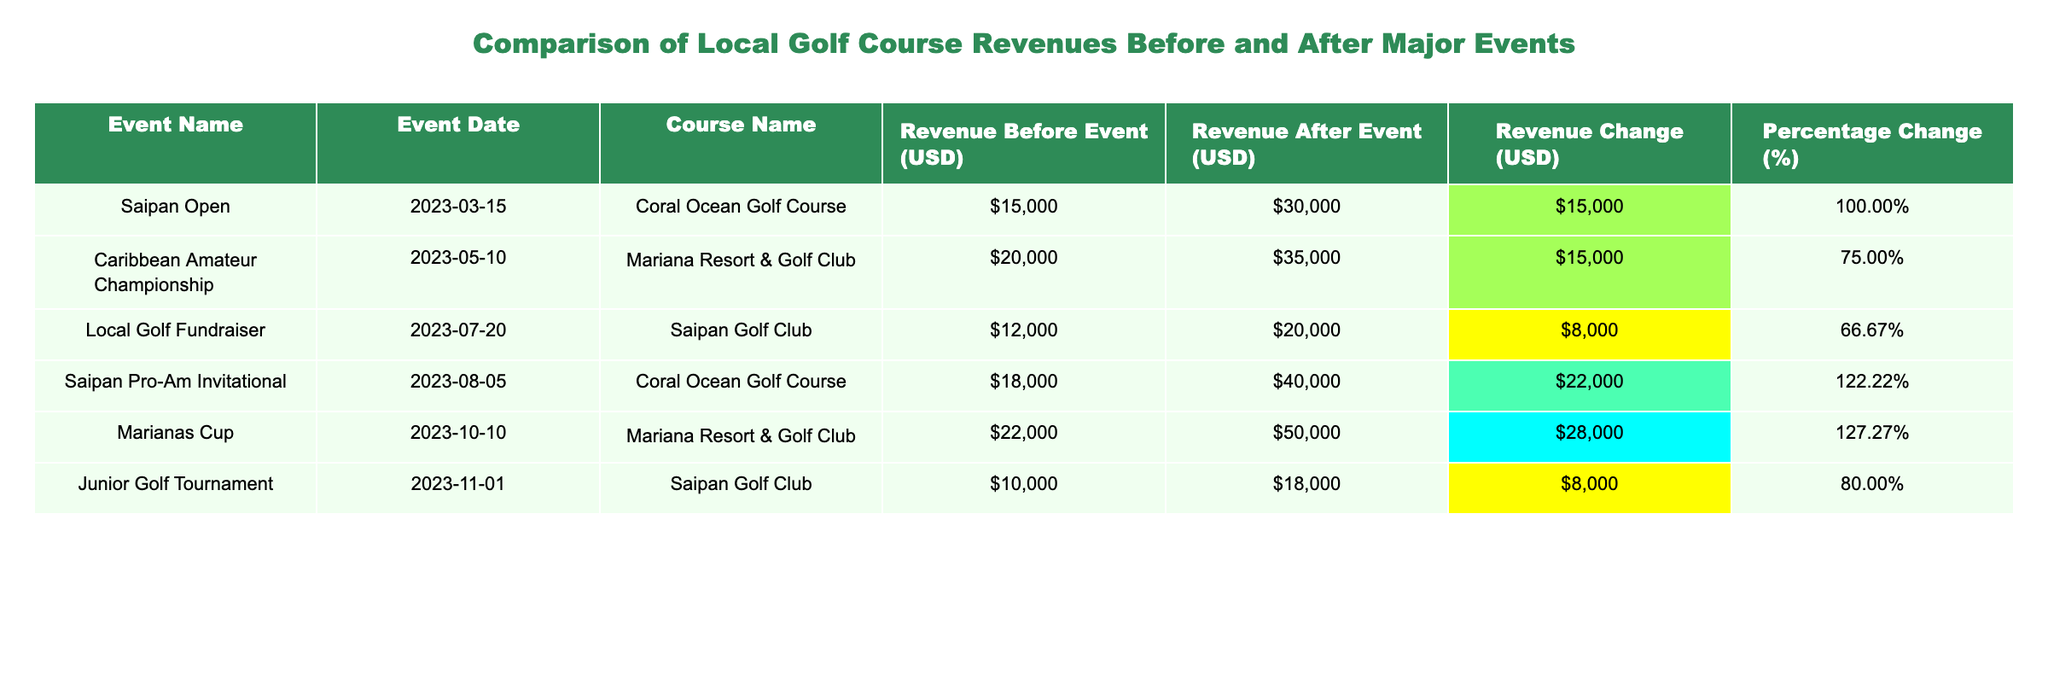What was the revenue before the Saipan Open event? The "Revenue Before Event (USD)" for the Saipan Open is directly listed as 15000.
Answer: 15000 What was the percentage change in revenue after the Junior Golf Tournament? The "Percentage Change (%)" for the Junior Golf Tournament is listed as 80%.
Answer: 80% Which event saw the highest revenue change in absolute terms? Looking at the "Revenue Change (USD)" column, the Saipan Pro-Am Invitational has the highest change at 22000.
Answer: 22000 What is the average revenue before the events listed? To find the average, sum the revenues before events (15000 + 20000 + 12000 + 18000 + 22000 + 10000 = 107000), then divide by the number of events (6), giving 107000 / 6 = 17833.33.
Answer: 17833.33 Did the Mariana Resort & Golf Club see an increase in revenue after both events it hosted? For the Caribbean Amateur Championship, revenue increased from 20000 to 35000, and for the Marianas Cup, it increased from 22000 to 50000, so both showed increases post-event.
Answer: Yes What is the difference in total revenue change between the Saipan Open and the Marianas Cup? The revenue change for the Saipan Open is 15000 and for the Marianas Cup it is 28000. The difference is calculated by 28000 - 15000 = 13000.
Answer: 13000 Was there any event that had revenue after the event lower than 30000? The Local Golf Fundraiser had revenue after the event listed as 20000, which is lower than 30000.
Answer: Yes Which golf course had the highest revenue after an event according to the table? The Marianas Cup held at Mariana Resort & Golf Club had the highest revenue after the event at 50000.
Answer: 50000 What is the total revenue change across all events listed? Summing all revenue changes gives 15000 + 15000 + 8000 + 22000 + 28000 + 8000 = 109000.
Answer: 109000 How many events resulted in a revenue increase of over 100%? Following the "Percentage Change (%)," the Saipan Pro-Am Invitational (122.22%) and the Marianas Cup (127.27%) both had increases over 100%. So, there are 2 events.
Answer: 2 If we consider only the Saipan Golf Club events, what was their total revenue change? The revenue change for the Local Golf Fundraiser is 8000 and for the Junior Golf Tournament is also 8000, summing these gives 8000 + 8000 = 16000.
Answer: 16000 